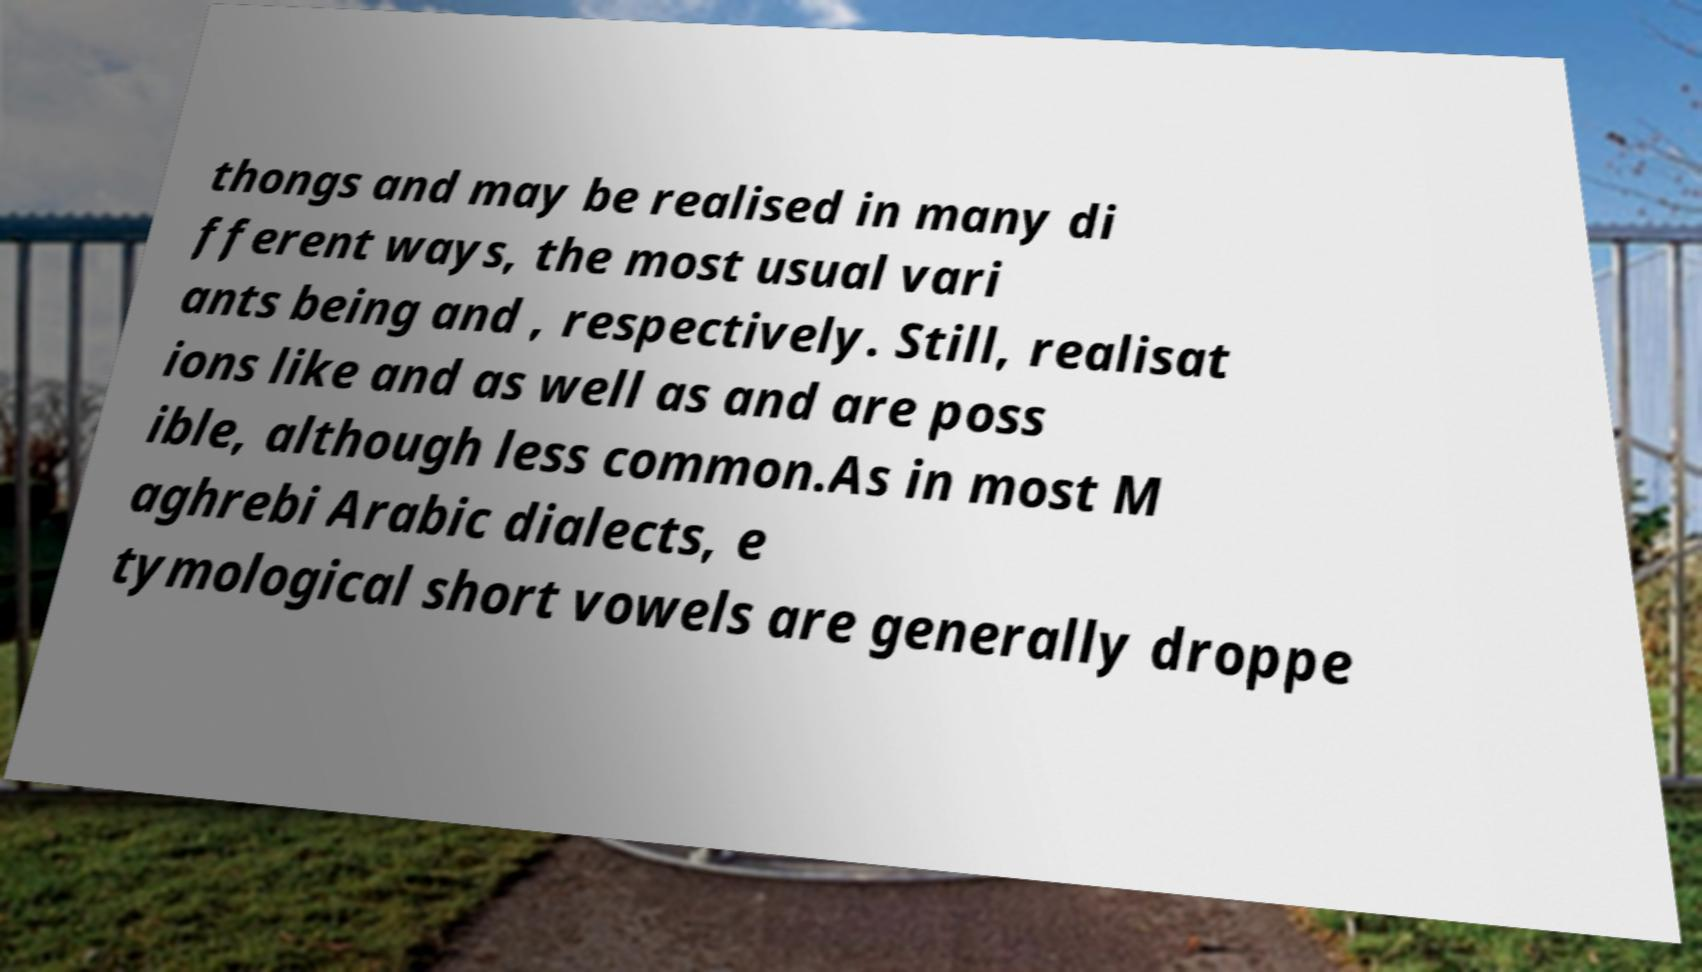I need the written content from this picture converted into text. Can you do that? thongs and may be realised in many di fferent ways, the most usual vari ants being and , respectively. Still, realisat ions like and as well as and are poss ible, although less common.As in most M aghrebi Arabic dialects, e tymological short vowels are generally droppe 